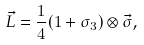<formula> <loc_0><loc_0><loc_500><loc_500>\vec { L } = \frac { 1 } { 4 } ( 1 + \sigma _ { 3 } ) \otimes \vec { \sigma } ,</formula> 